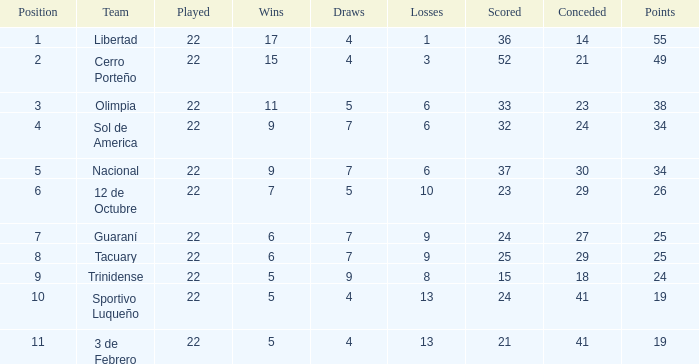Write the full table. {'header': ['Position', 'Team', 'Played', 'Wins', 'Draws', 'Losses', 'Scored', 'Conceded', 'Points'], 'rows': [['1', 'Libertad', '22', '17', '4', '1', '36', '14', '55'], ['2', 'Cerro Porteño', '22', '15', '4', '3', '52', '21', '49'], ['3', 'Olimpia', '22', '11', '5', '6', '33', '23', '38'], ['4', 'Sol de America', '22', '9', '7', '6', '32', '24', '34'], ['5', 'Nacional', '22', '9', '7', '6', '37', '30', '34'], ['6', '12 de Octubre', '22', '7', '5', '10', '23', '29', '26'], ['7', 'Guaraní', '22', '6', '7', '9', '24', '27', '25'], ['8', 'Tacuary', '22', '6', '7', '9', '25', '29', '25'], ['9', 'Trinidense', '22', '5', '9', '8', '15', '18', '24'], ['10', 'Sportivo Luqueño', '22', '5', '4', '13', '24', '41', '19'], ['11', '3 de Febrero', '22', '5', '4', '13', '21', '41', '19']]} How many losses occurred when the scored value amounted to 25? 9.0. 